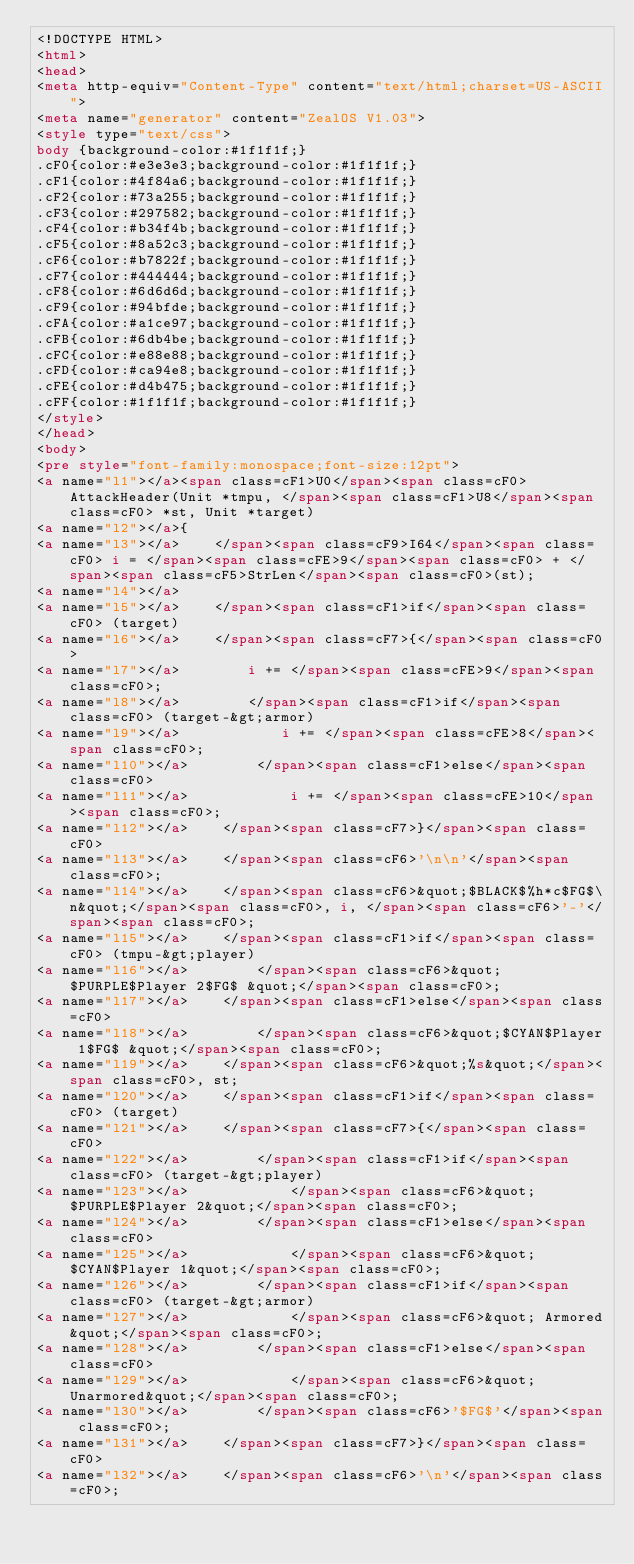Convert code to text. <code><loc_0><loc_0><loc_500><loc_500><_HTML_><!DOCTYPE HTML>
<html>
<head>
<meta http-equiv="Content-Type" content="text/html;charset=US-ASCII">
<meta name="generator" content="ZealOS V1.03">
<style type="text/css">
body {background-color:#1f1f1f;}
.cF0{color:#e3e3e3;background-color:#1f1f1f;}
.cF1{color:#4f84a6;background-color:#1f1f1f;}
.cF2{color:#73a255;background-color:#1f1f1f;}
.cF3{color:#297582;background-color:#1f1f1f;}
.cF4{color:#b34f4b;background-color:#1f1f1f;}
.cF5{color:#8a52c3;background-color:#1f1f1f;}
.cF6{color:#b7822f;background-color:#1f1f1f;}
.cF7{color:#444444;background-color:#1f1f1f;}
.cF8{color:#6d6d6d;background-color:#1f1f1f;}
.cF9{color:#94bfde;background-color:#1f1f1f;}
.cFA{color:#a1ce97;background-color:#1f1f1f;}
.cFB{color:#6db4be;background-color:#1f1f1f;}
.cFC{color:#e88e88;background-color:#1f1f1f;}
.cFD{color:#ca94e8;background-color:#1f1f1f;}
.cFE{color:#d4b475;background-color:#1f1f1f;}
.cFF{color:#1f1f1f;background-color:#1f1f1f;}
</style>
</head>
<body>
<pre style="font-family:monospace;font-size:12pt">
<a name="l1"></a><span class=cF1>U0</span><span class=cF0> AttackHeader(Unit *tmpu, </span><span class=cF1>U8</span><span class=cF0> *st, Unit *target)
<a name="l2"></a>{
<a name="l3"></a>    </span><span class=cF9>I64</span><span class=cF0> i = </span><span class=cFE>9</span><span class=cF0> + </span><span class=cF5>StrLen</span><span class=cF0>(st);
<a name="l4"></a>
<a name="l5"></a>    </span><span class=cF1>if</span><span class=cF0> (target)
<a name="l6"></a>    </span><span class=cF7>{</span><span class=cF0>
<a name="l7"></a>        i += </span><span class=cFE>9</span><span class=cF0>;
<a name="l8"></a>        </span><span class=cF1>if</span><span class=cF0> (target-&gt;armor)
<a name="l9"></a>            i += </span><span class=cFE>8</span><span class=cF0>;
<a name="l10"></a>        </span><span class=cF1>else</span><span class=cF0>
<a name="l11"></a>            i += </span><span class=cFE>10</span><span class=cF0>;
<a name="l12"></a>    </span><span class=cF7>}</span><span class=cF0>
<a name="l13"></a>    </span><span class=cF6>'\n\n'</span><span class=cF0>;
<a name="l14"></a>    </span><span class=cF6>&quot;$BLACK$%h*c$FG$\n&quot;</span><span class=cF0>, i, </span><span class=cF6>'-'</span><span class=cF0>;
<a name="l15"></a>    </span><span class=cF1>if</span><span class=cF0> (tmpu-&gt;player)
<a name="l16"></a>        </span><span class=cF6>&quot;$PURPLE$Player 2$FG$ &quot;</span><span class=cF0>;
<a name="l17"></a>    </span><span class=cF1>else</span><span class=cF0>
<a name="l18"></a>        </span><span class=cF6>&quot;$CYAN$Player 1$FG$ &quot;</span><span class=cF0>;
<a name="l19"></a>    </span><span class=cF6>&quot;%s&quot;</span><span class=cF0>, st;
<a name="l20"></a>    </span><span class=cF1>if</span><span class=cF0> (target)
<a name="l21"></a>    </span><span class=cF7>{</span><span class=cF0>
<a name="l22"></a>        </span><span class=cF1>if</span><span class=cF0> (target-&gt;player)
<a name="l23"></a>            </span><span class=cF6>&quot; $PURPLE$Player 2&quot;</span><span class=cF0>;
<a name="l24"></a>        </span><span class=cF1>else</span><span class=cF0>
<a name="l25"></a>            </span><span class=cF6>&quot; $CYAN$Player 1&quot;</span><span class=cF0>;
<a name="l26"></a>        </span><span class=cF1>if</span><span class=cF0> (target-&gt;armor)
<a name="l27"></a>            </span><span class=cF6>&quot; Armored&quot;</span><span class=cF0>;
<a name="l28"></a>        </span><span class=cF1>else</span><span class=cF0>
<a name="l29"></a>            </span><span class=cF6>&quot; Unarmored&quot;</span><span class=cF0>;
<a name="l30"></a>        </span><span class=cF6>'$FG$'</span><span class=cF0>;
<a name="l31"></a>    </span><span class=cF7>}</span><span class=cF0>
<a name="l32"></a>    </span><span class=cF6>'\n'</span><span class=cF0>;</code> 